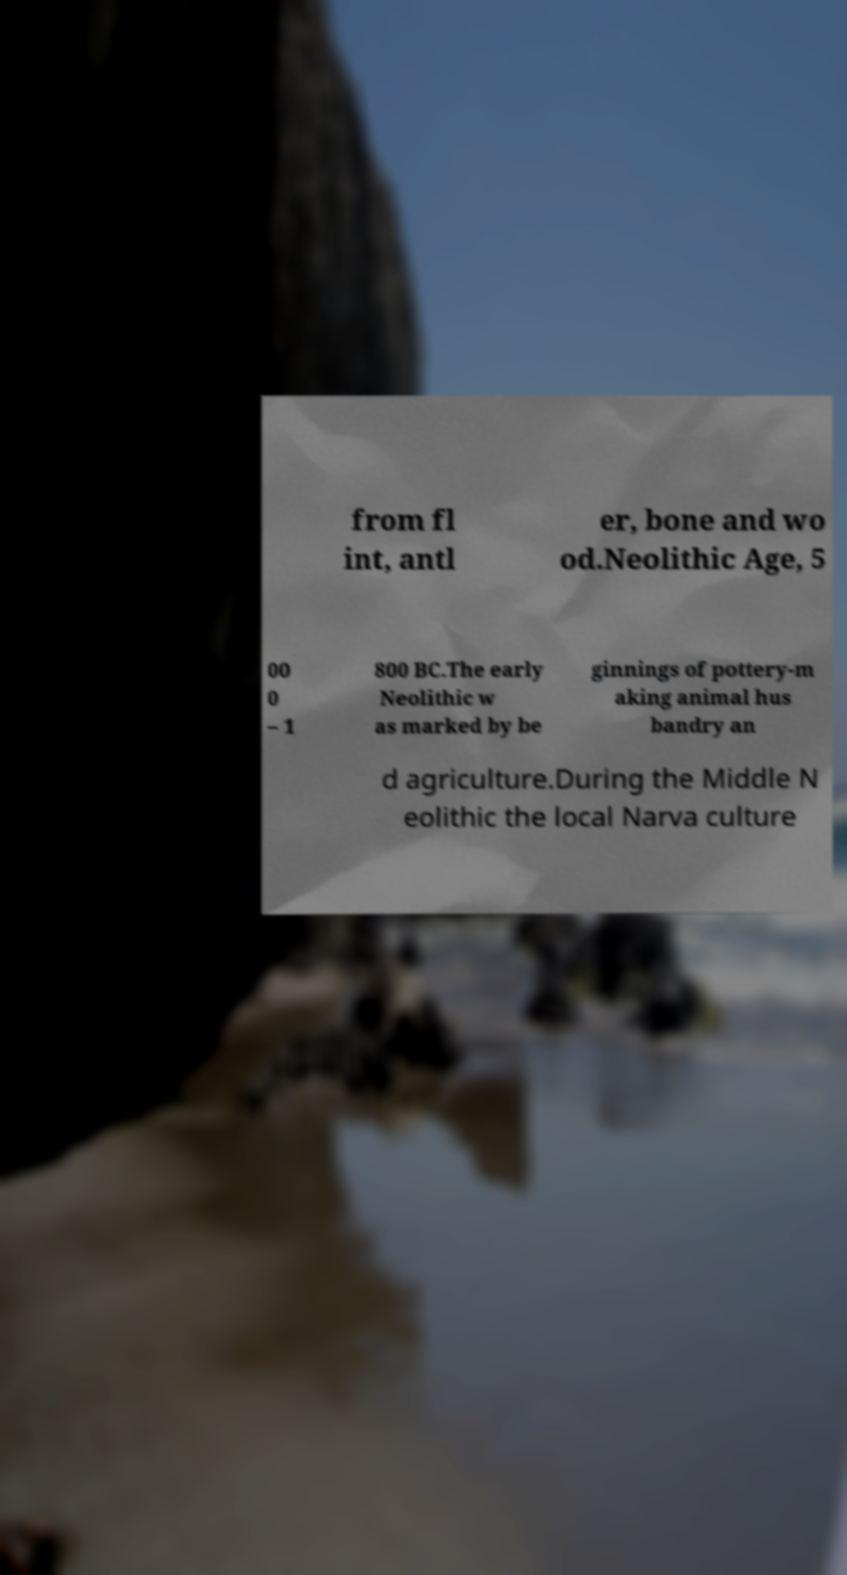Could you extract and type out the text from this image? from fl int, antl er, bone and wo od.Neolithic Age, 5 00 0 – 1 800 BC.The early Neolithic w as marked by be ginnings of pottery-m aking animal hus bandry an d agriculture.During the Middle N eolithic the local Narva culture 